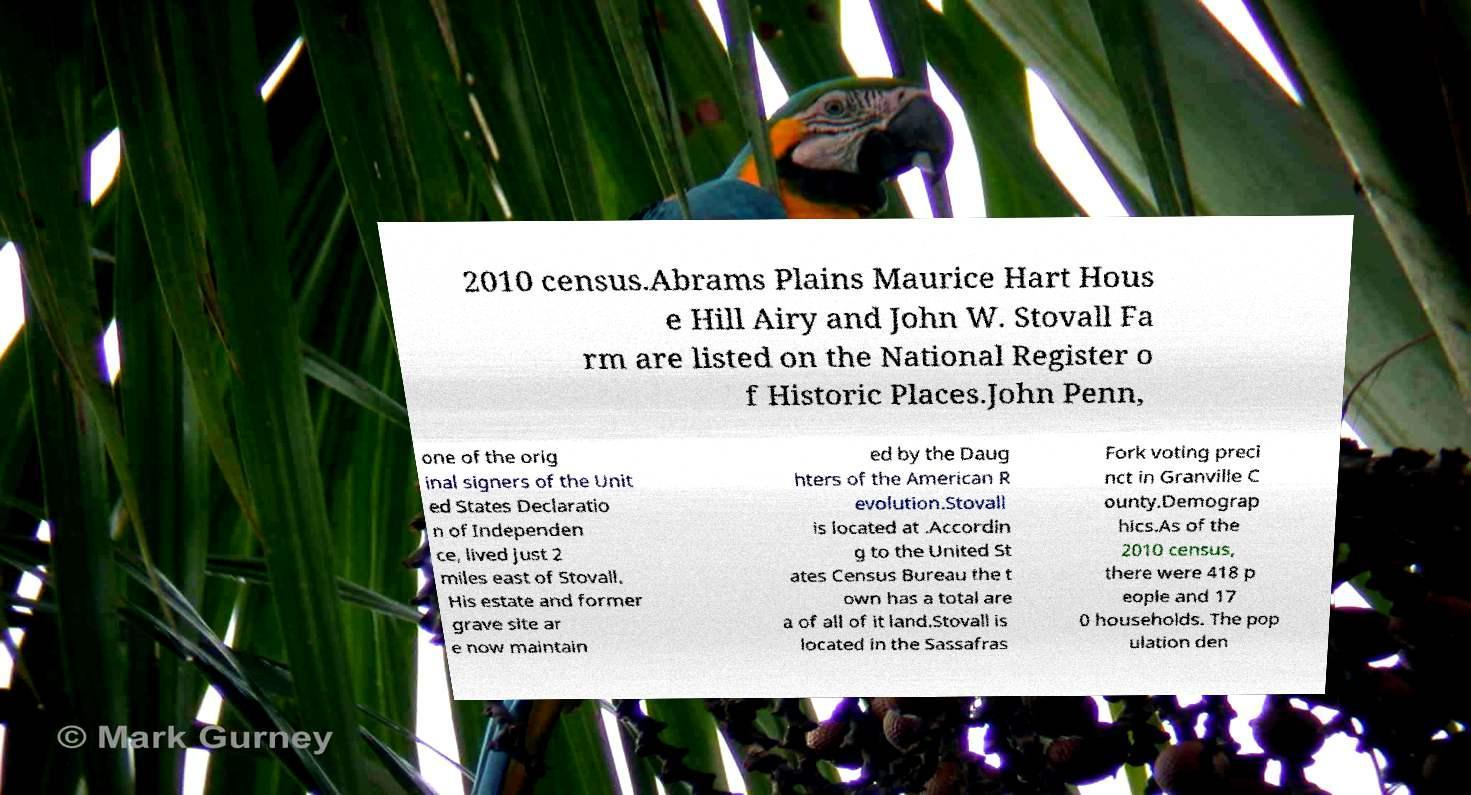Could you extract and type out the text from this image? 2010 census.Abrams Plains Maurice Hart Hous e Hill Airy and John W. Stovall Fa rm are listed on the National Register o f Historic Places.John Penn, one of the orig inal signers of the Unit ed States Declaratio n of Independen ce, lived just 2 miles east of Stovall. His estate and former grave site ar e now maintain ed by the Daug hters of the American R evolution.Stovall is located at .Accordin g to the United St ates Census Bureau the t own has a total are a of all of it land.Stovall is located in the Sassafras Fork voting preci nct in Granville C ounty.Demograp hics.As of the 2010 census, there were 418 p eople and 17 0 households. The pop ulation den 